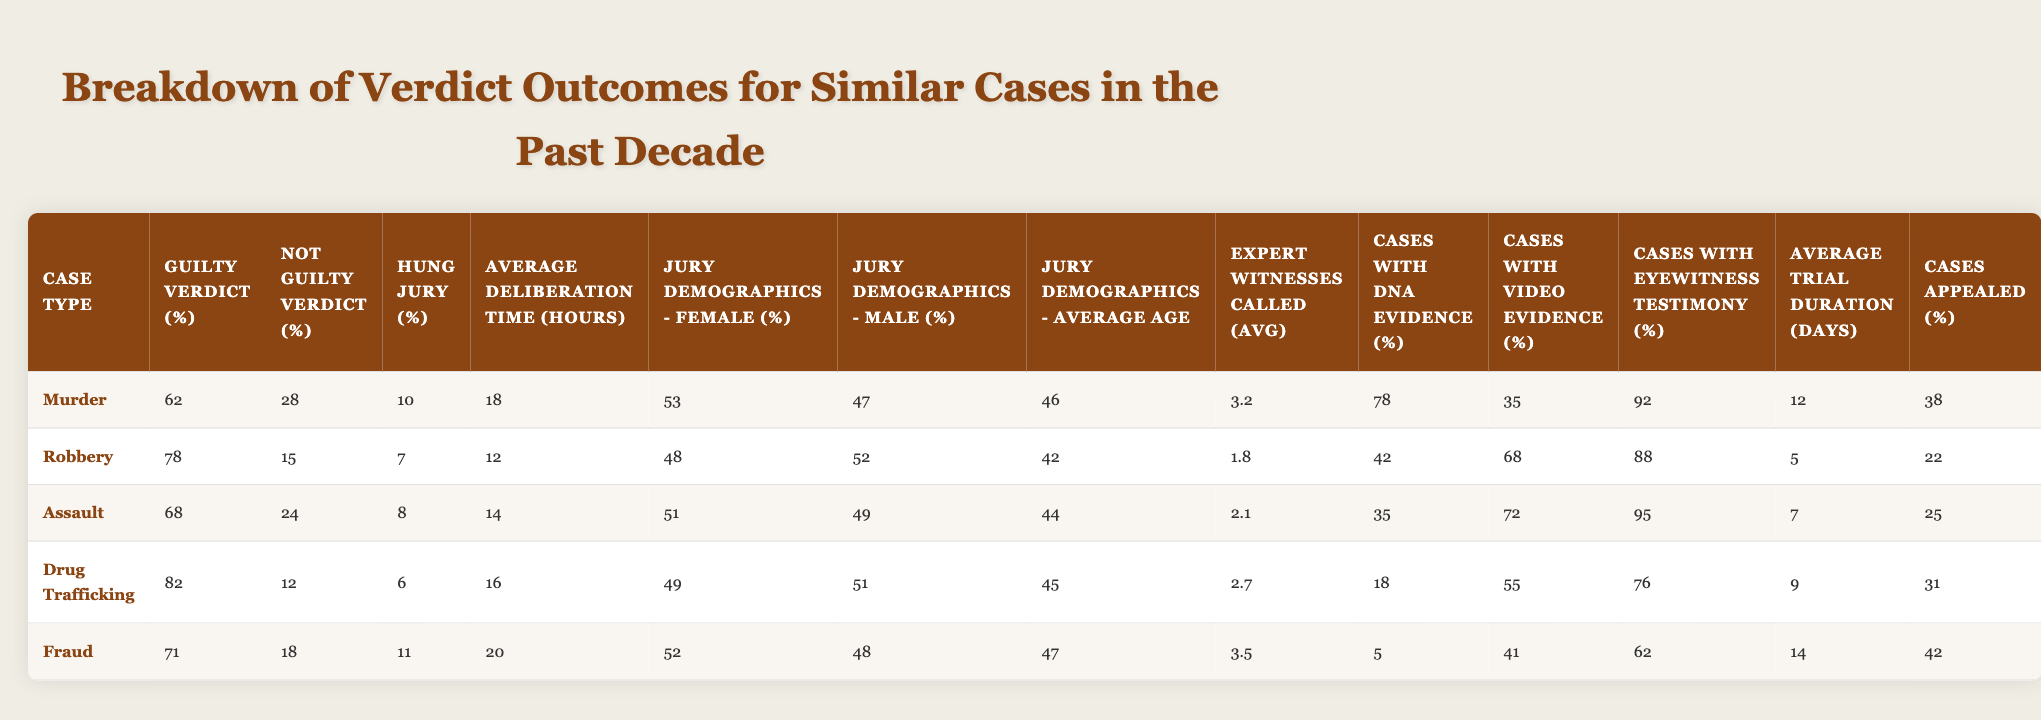What's the highest percentage of guilty verdicts among the case types? The "Guilty Verdict (%)" for each case type is as follows: Murder (62%), Robbery (78%), Assault (68%), Drug Trafficking (82%), and Fraud (71%). The highest percentage is Drug Trafficking with 82%.
Answer: 82% What is the average age of jurors for Drug Trafficking cases? The "Jury Demographics - Average Age" for Drug Trafficking is listed as 45 years.
Answer: 45 Which case type has the lowest percentage of cases with DNA evidence? The "Cases with DNA Evidence (%)" shows Drug Trafficking has the lowest percentage at 18%.
Answer: 18% How much longer did juries deliberate on average for Fraud cases compared to Robbery cases? The average deliberation time for Fraud is 20 hours, and for Robbery, it is 12 hours. The difference is 20 - 12 = 8 hours.
Answer: 8 hours Do the majority of cases with eyewitness testimony lead to guilty verdicts? The percentage of cases with eyewitness testimony is 95% for Assault and has a guilty verdict percentage of 68%. This shows that even with a high eyewitness testimony percentage, the guilty verdict is not over 80%, indicating that not all lead to guilty verdicts.
Answer: No Which case type had the highest average trial duration? The "Average Trial Duration (days)" for Fraud is 14 days, which is higher than the others: 12 for Murder, 5 for Robbery, 7 for Assault, and 9 for Drug Trafficking.
Answer: 14 days What is the average percentage of cases appealed across all case types? The appeal percentages are: Murder (38%), Robbery (22%), Assault (25%), Drug Trafficking (31%), and Fraud (42%), which totals to 158%. Dividing by 5 gives an average of 31.6%.
Answer: 31.6% Are there more female jurors than male jurors on average across all case types? The average percentages are calculated: Female: (53 + 48 + 51 + 49 + 52) / 5 = 50.6%, Male: (47 + 52 + 49 + 51 + 48) / 5 = 49.4%. Female jurors slightly outnumber male jurors on average.
Answer: Yes What percentage of the Robbery cases received a not guilty verdict? The "Not Guilty Verdict (%)" for Robbery is 15%.
Answer: 15% Does Drug Trafficking have the highest proportion of expert witnesses called? The average number of expert witnesses called for Drug Trafficking is 2.7, while Fraud has 3.5 experts, indicating Drug Trafficking does not have the highest.
Answer: No What is the difference in the average deliberation time for Murder and Fraud cases? The average deliberation time for Murder is 18 hours and for Fraud is 20 hours, resulting in a difference of 20 - 18 = 2 hours.
Answer: 2 hours 